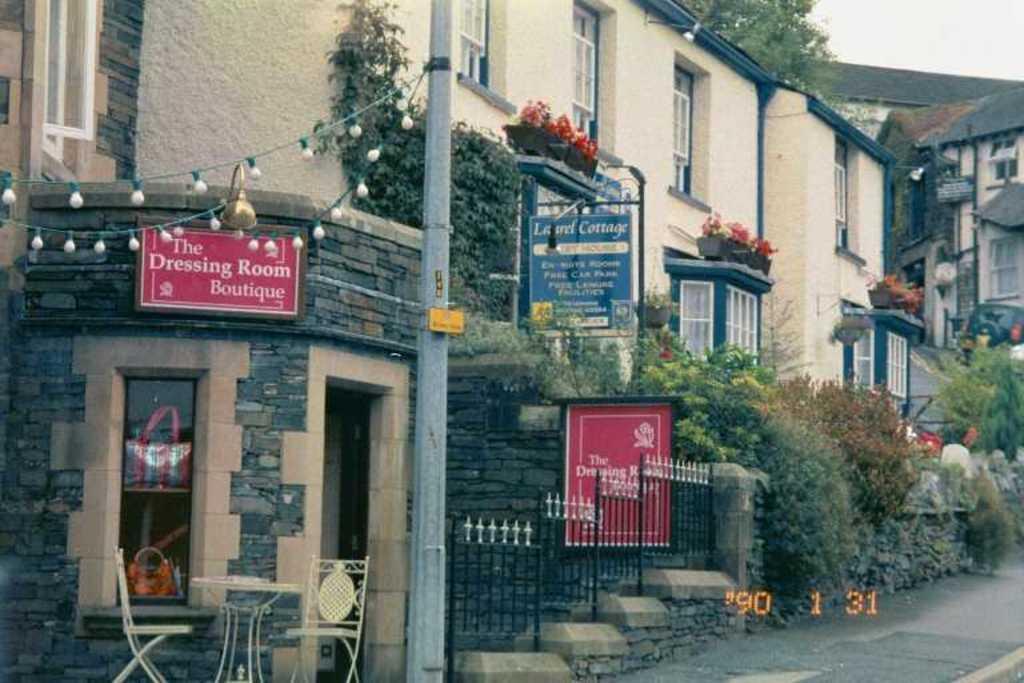Could you give a brief overview of what you see in this image? In the foreground of this image, there is a side path at the bottom. We can also see a railing, pole, lights, boards, chairs, a table, potted plants, buildings, creepers, wall, tree and the sky. 